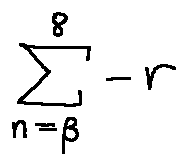<formula> <loc_0><loc_0><loc_500><loc_500>\sum \lim i t s _ { n = \beta } ^ { 8 } - r</formula> 